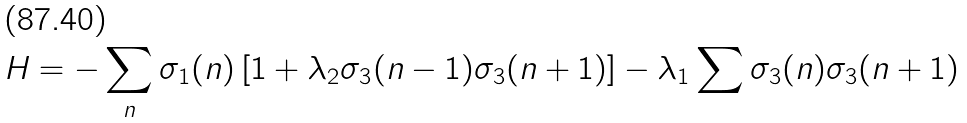Convert formula to latex. <formula><loc_0><loc_0><loc_500><loc_500>H = - \sum _ { n } \sigma _ { 1 } ( n ) \left [ 1 + \lambda _ { 2 } \sigma _ { 3 } ( n - 1 ) \sigma _ { 3 } ( n + 1 ) \right ] - \lambda _ { 1 } \sum \sigma _ { 3 } ( n ) \sigma _ { 3 } ( n + 1 )</formula> 